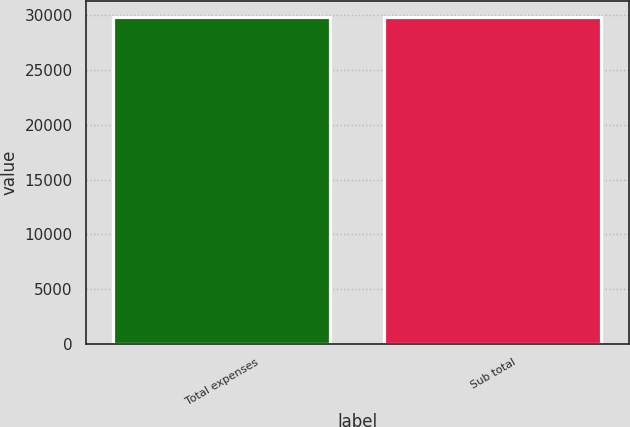Convert chart. <chart><loc_0><loc_0><loc_500><loc_500><bar_chart><fcel>Total expenses<fcel>Sub total<nl><fcel>29827<fcel>29827.1<nl></chart> 